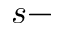Convert formula to latex. <formula><loc_0><loc_0><loc_500><loc_500>s -</formula> 